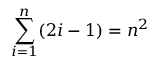<formula> <loc_0><loc_0><loc_500><loc_500>\sum _ { i = 1 } ^ { n } ( 2 i - 1 ) = n ^ { 2 }</formula> 